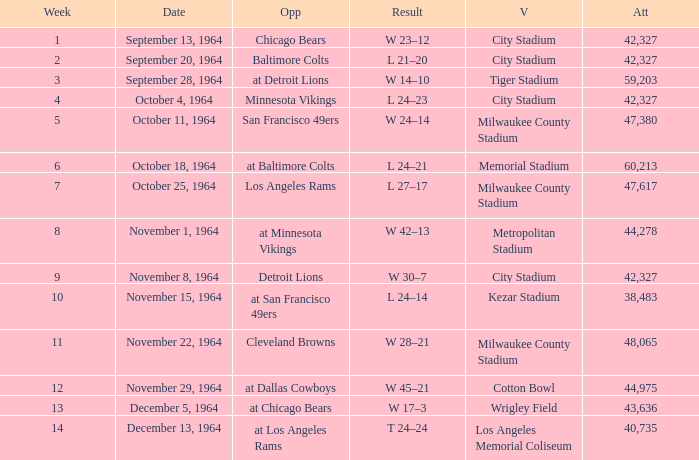What is the average week of the game on November 22, 1964 attended by 48,065? None. Could you parse the entire table? {'header': ['Week', 'Date', 'Opp', 'Result', 'V', 'Att'], 'rows': [['1', 'September 13, 1964', 'Chicago Bears', 'W 23–12', 'City Stadium', '42,327'], ['2', 'September 20, 1964', 'Baltimore Colts', 'L 21–20', 'City Stadium', '42,327'], ['3', 'September 28, 1964', 'at Detroit Lions', 'W 14–10', 'Tiger Stadium', '59,203'], ['4', 'October 4, 1964', 'Minnesota Vikings', 'L 24–23', 'City Stadium', '42,327'], ['5', 'October 11, 1964', 'San Francisco 49ers', 'W 24–14', 'Milwaukee County Stadium', '47,380'], ['6', 'October 18, 1964', 'at Baltimore Colts', 'L 24–21', 'Memorial Stadium', '60,213'], ['7', 'October 25, 1964', 'Los Angeles Rams', 'L 27–17', 'Milwaukee County Stadium', '47,617'], ['8', 'November 1, 1964', 'at Minnesota Vikings', 'W 42–13', 'Metropolitan Stadium', '44,278'], ['9', 'November 8, 1964', 'Detroit Lions', 'W 30–7', 'City Stadium', '42,327'], ['10', 'November 15, 1964', 'at San Francisco 49ers', 'L 24–14', 'Kezar Stadium', '38,483'], ['11', 'November 22, 1964', 'Cleveland Browns', 'W 28–21', 'Milwaukee County Stadium', '48,065'], ['12', 'November 29, 1964', 'at Dallas Cowboys', 'W 45–21', 'Cotton Bowl', '44,975'], ['13', 'December 5, 1964', 'at Chicago Bears', 'W 17–3', 'Wrigley Field', '43,636'], ['14', 'December 13, 1964', 'at Los Angeles Rams', 'T 24–24', 'Los Angeles Memorial Coliseum', '40,735']]} 